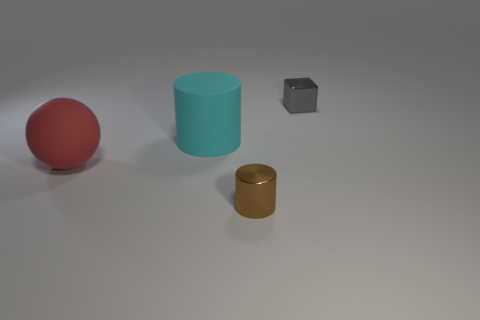Subtract 1 cylinders. How many cylinders are left? 1 Add 3 blue metal objects. How many objects exist? 7 Subtract all cyan cylinders. How many cylinders are left? 1 Add 4 small cylinders. How many small cylinders are left? 5 Add 3 brown metallic things. How many brown metallic things exist? 4 Subtract 0 brown balls. How many objects are left? 4 Subtract all spheres. How many objects are left? 3 Subtract all green cylinders. Subtract all cyan cubes. How many cylinders are left? 2 Subtract all blue spheres. How many cyan cylinders are left? 1 Subtract all large red matte spheres. Subtract all cylinders. How many objects are left? 1 